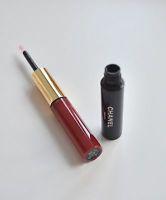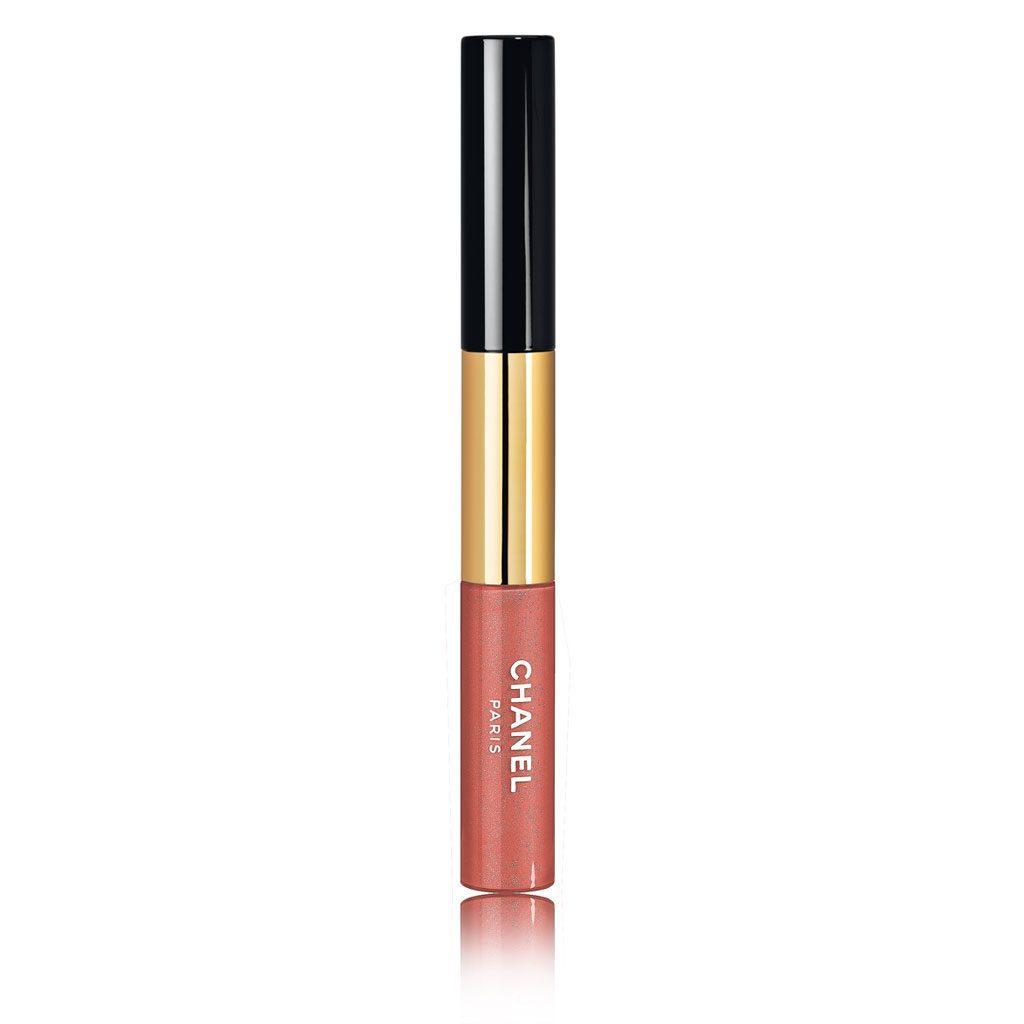The first image is the image on the left, the second image is the image on the right. For the images displayed, is the sentence "All lip makeups shown come in cylindrical bottles with clear glass that shows the reddish-purple color of the lip tint." factually correct? Answer yes or no. No. The first image is the image on the left, the second image is the image on the right. For the images displayed, is the sentence "All the items are capped." factually correct? Answer yes or no. No. 